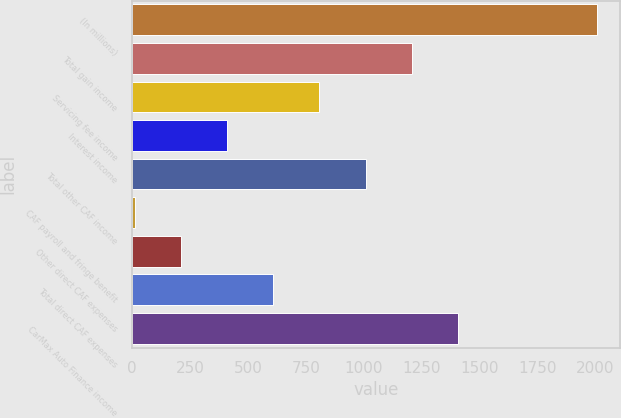Convert chart. <chart><loc_0><loc_0><loc_500><loc_500><bar_chart><fcel>(In millions)<fcel>Total gain income<fcel>Servicing fee income<fcel>Interest income<fcel>Total other CAF income<fcel>CAF payroll and fringe benefit<fcel>Other direct CAF expenses<fcel>Total direct CAF expenses<fcel>CarMax Auto Finance income<nl><fcel>2006<fcel>1207.72<fcel>808.58<fcel>409.44<fcel>1008.15<fcel>10.3<fcel>209.87<fcel>609.01<fcel>1407.29<nl></chart> 